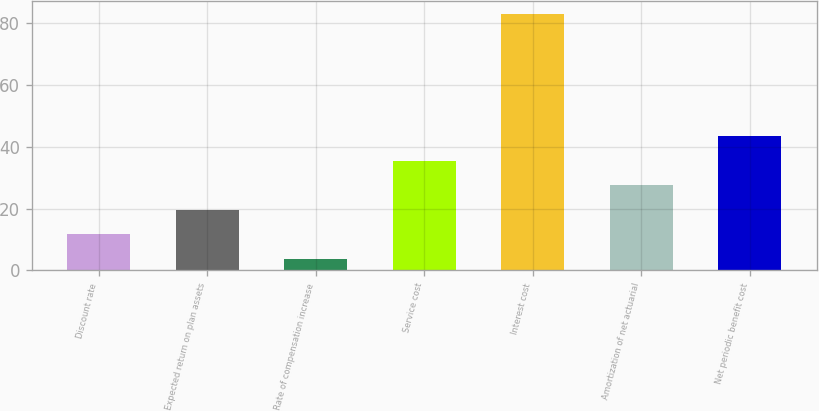<chart> <loc_0><loc_0><loc_500><loc_500><bar_chart><fcel>Discount rate<fcel>Expected return on plan assets<fcel>Rate of compensation increase<fcel>Service cost<fcel>Interest cost<fcel>Amortization of net actuarial<fcel>Net periodic benefit cost<nl><fcel>11.68<fcel>19.61<fcel>3.75<fcel>35.47<fcel>83<fcel>27.54<fcel>43.39<nl></chart> 